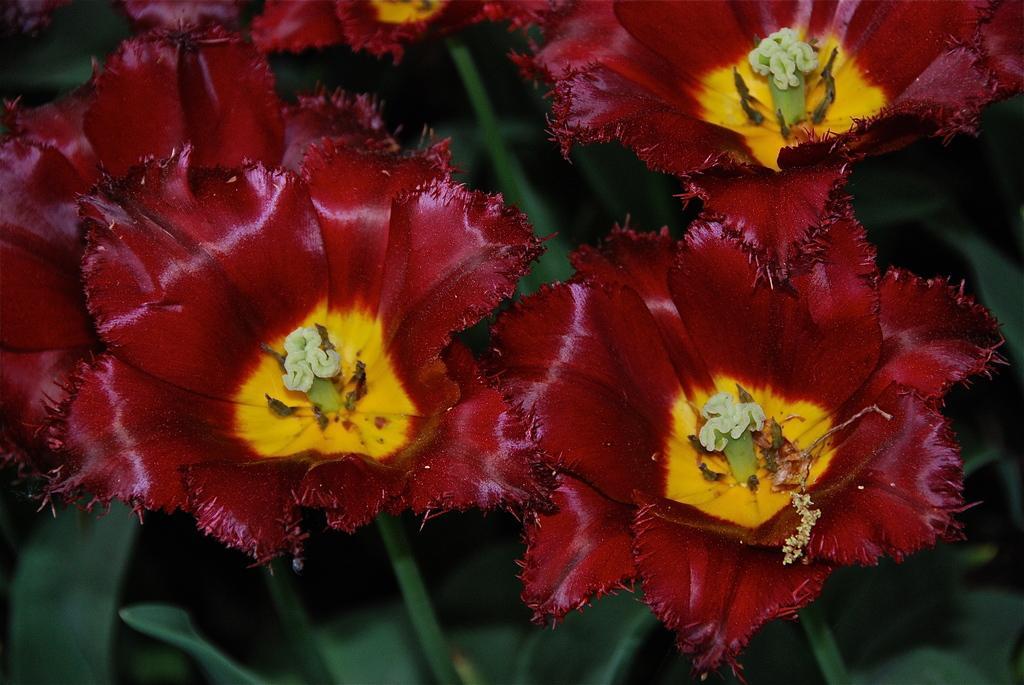How would you summarize this image in a sentence or two? In this picture there are maroon color flowers on the plants. 